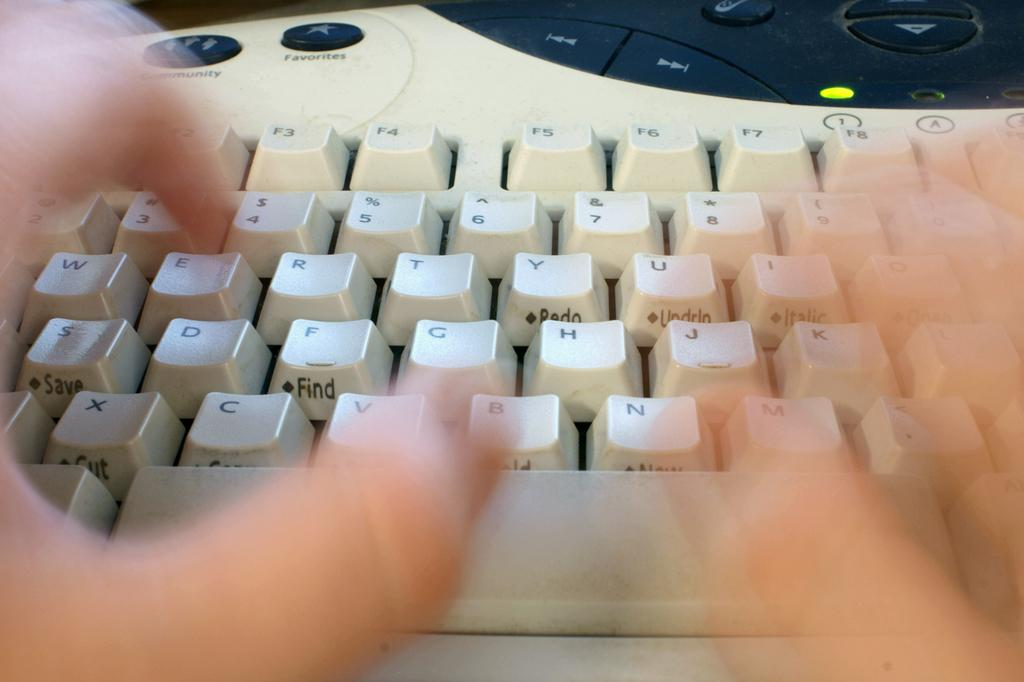<image>
Create a compact narrative representing the image presented. A person typing at a keyboard has their thumb above the letter B 